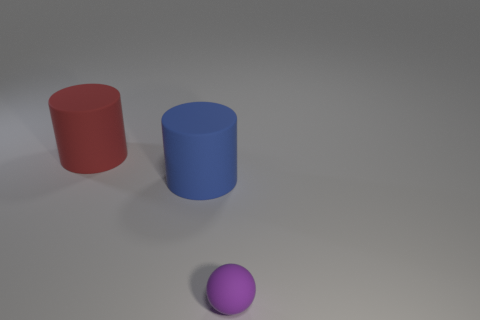What is the material of the large cylinder that is in front of the red matte cylinder?
Keep it short and to the point. Rubber. Are there fewer objects that are right of the rubber ball than green metal cylinders?
Make the answer very short. No. There is a small rubber thing that is in front of the large object that is left of the big blue object; what is its shape?
Offer a very short reply. Sphere. The tiny sphere is what color?
Provide a short and direct response. Purple. What number of other things are there of the same size as the ball?
Ensure brevity in your answer.  0. What is the object that is behind the small sphere and in front of the red rubber object made of?
Provide a succinct answer. Rubber. There is a rubber cylinder in front of the red rubber thing; does it have the same size as the purple matte ball?
Your answer should be very brief. No. What number of large cylinders are both behind the big blue matte object and in front of the big red matte cylinder?
Offer a very short reply. 0. There is a purple object that is on the right side of the large cylinder that is in front of the big red rubber object; how many things are in front of it?
Give a very brief answer. 0. What is the shape of the big blue object?
Give a very brief answer. Cylinder. 